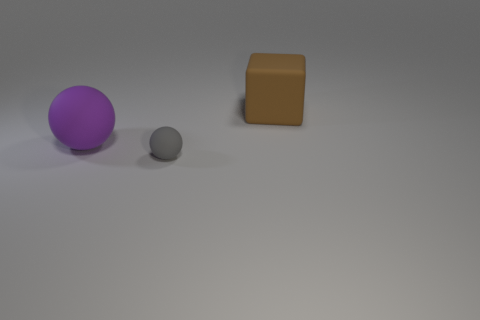Add 1 small blue rubber balls. How many objects exist? 4 Subtract all spheres. How many objects are left? 1 Subtract 0 blue blocks. How many objects are left? 3 Subtract all tiny brown cylinders. Subtract all big purple balls. How many objects are left? 2 Add 3 big balls. How many big balls are left? 4 Add 2 big purple balls. How many big purple balls exist? 3 